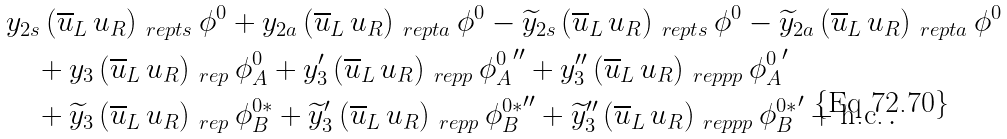<formula> <loc_0><loc_0><loc_500><loc_500>& y _ { 2 s } \, ( \overline { u } _ { L } \, u _ { R } ) _ { \ r e p t s } \, \phi ^ { 0 } + y _ { 2 a } \, ( \overline { u } _ { L } \, u _ { R } ) _ { \ r e p t a } \, \phi ^ { 0 } - \widetilde { y } _ { 2 s } \, ( \overline { u } _ { L } \, u _ { R } ) _ { \ r e p t s } \, \phi ^ { 0 } - \widetilde { y } _ { 2 a } \, ( \overline { u } _ { L } \, u _ { R } ) _ { \ r e p t a } \, \phi ^ { 0 } \\ & \quad + y _ { 3 } \, ( \overline { u } _ { L } \, u _ { R } ) _ { \ r e p } \, \phi ^ { 0 } _ { A } + y _ { 3 } ^ { \prime } \, ( \overline { u } _ { L } \, u _ { R } ) _ { \ r e p p } \, { \phi ^ { 0 } _ { A } } ^ { \prime \prime } + y _ { 3 } ^ { \prime \prime } \, ( \overline { u } _ { L } \, u _ { R } ) _ { \ r e p p p } \, { \phi ^ { 0 } _ { A } } ^ { \prime } \\ & \quad + \widetilde { y } _ { 3 } \, ( \overline { u } _ { L } \, u _ { R } ) _ { \ r e p } \, \phi ^ { 0 * } _ { B } + \widetilde { y } _ { 3 } ^ { \prime } \, ( \overline { u } _ { L } \, u _ { R } ) _ { \ r e p p } \, { \phi ^ { 0 * } _ { B } } ^ { \prime \prime } + \widetilde { y } _ { 3 } ^ { \prime \prime } \, ( \overline { u } _ { L } \, u _ { R } ) _ { \ r e p p p } \, { \phi ^ { 0 * } _ { B } } ^ { \prime } + \text {h.c.} \, .</formula> 